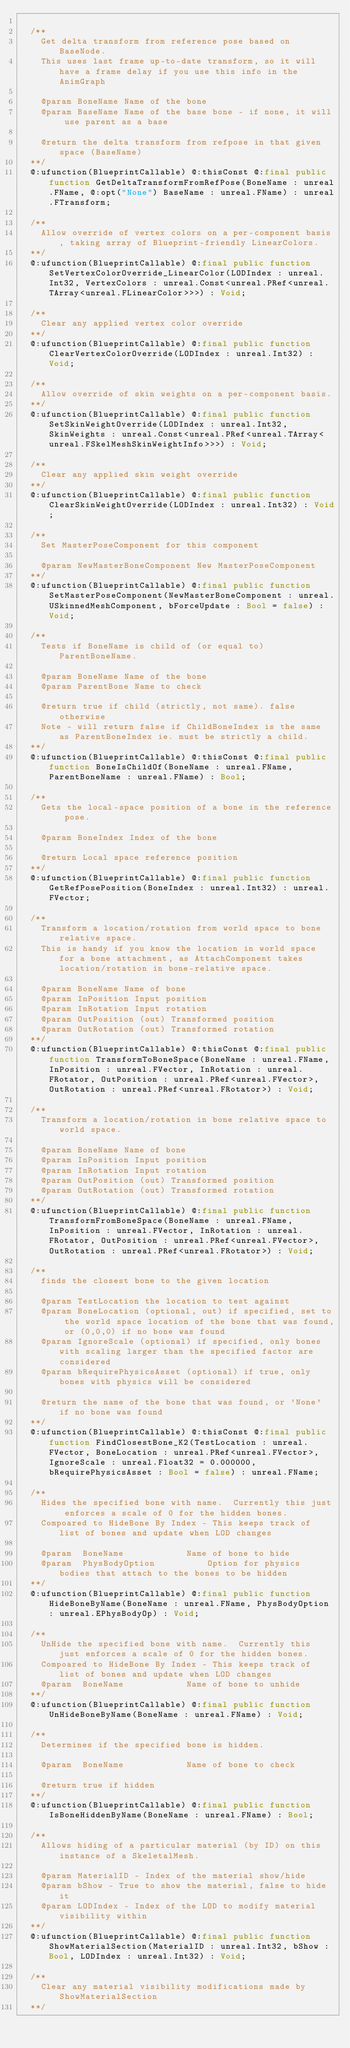<code> <loc_0><loc_0><loc_500><loc_500><_Haxe_>  
  /**
    Get delta transform from reference pose based on BaseNode.
    This uses last frame up-to-date transform, so it will have a frame delay if you use this info in the AnimGraph
    
    @param BoneName Name of the bone
    @param BaseName Name of the base bone - if none, it will use parent as a base
    
    @return the delta transform from refpose in that given space (BaseName)
  **/
  @:ufunction(BlueprintCallable) @:thisConst @:final public function GetDeltaTransformFromRefPose(BoneName : unreal.FName, @:opt("None") BaseName : unreal.FName) : unreal.FTransform;
  
  /**
    Allow override of vertex colors on a per-component basis, taking array of Blueprint-friendly LinearColors.
  **/
  @:ufunction(BlueprintCallable) @:final public function SetVertexColorOverride_LinearColor(LODIndex : unreal.Int32, VertexColors : unreal.Const<unreal.PRef<unreal.TArray<unreal.FLinearColor>>>) : Void;
  
  /**
    Clear any applied vertex color override
  **/
  @:ufunction(BlueprintCallable) @:final public function ClearVertexColorOverride(LODIndex : unreal.Int32) : Void;
  
  /**
    Allow override of skin weights on a per-component basis.
  **/
  @:ufunction(BlueprintCallable) @:final public function SetSkinWeightOverride(LODIndex : unreal.Int32, SkinWeights : unreal.Const<unreal.PRef<unreal.TArray<unreal.FSkelMeshSkinWeightInfo>>>) : Void;
  
  /**
    Clear any applied skin weight override
  **/
  @:ufunction(BlueprintCallable) @:final public function ClearSkinWeightOverride(LODIndex : unreal.Int32) : Void;
  
  /**
    Set MasterPoseComponent for this component
    
    @param NewMasterBoneComponent New MasterPoseComponent
  **/
  @:ufunction(BlueprintCallable) @:final public function SetMasterPoseComponent(NewMasterBoneComponent : unreal.USkinnedMeshComponent, bForceUpdate : Bool = false) : Void;
  
  /**
    Tests if BoneName is child of (or equal to) ParentBoneName.
    
    @param BoneName Name of the bone
    @param ParentBone Name to check
    
    @return true if child (strictly, not same). false otherwise
    Note - will return false if ChildBoneIndex is the same as ParentBoneIndex ie. must be strictly a child.
  **/
  @:ufunction(BlueprintCallable) @:thisConst @:final public function BoneIsChildOf(BoneName : unreal.FName, ParentBoneName : unreal.FName) : Bool;
  
  /**
    Gets the local-space position of a bone in the reference pose.
    
    @param BoneIndex Index of the bone
    
    @return Local space reference position
  **/
  @:ufunction(BlueprintCallable) @:final public function GetRefPosePosition(BoneIndex : unreal.Int32) : unreal.FVector;
  
  /**
    Transform a location/rotation from world space to bone relative space.
    This is handy if you know the location in world space for a bone attachment, as AttachComponent takes location/rotation in bone-relative space.
    
    @param BoneName Name of bone
    @param InPosition Input position
    @param InRotation Input rotation
    @param OutPosition (out) Transformed position
    @param OutRotation (out) Transformed rotation
  **/
  @:ufunction(BlueprintCallable) @:thisConst @:final public function TransformToBoneSpace(BoneName : unreal.FName, InPosition : unreal.FVector, InRotation : unreal.FRotator, OutPosition : unreal.PRef<unreal.FVector>, OutRotation : unreal.PRef<unreal.FRotator>) : Void;
  
  /**
    Transform a location/rotation in bone relative space to world space.
    
    @param BoneName Name of bone
    @param InPosition Input position
    @param InRotation Input rotation
    @param OutPosition (out) Transformed position
    @param OutRotation (out) Transformed rotation
  **/
  @:ufunction(BlueprintCallable) @:final public function TransformFromBoneSpace(BoneName : unreal.FName, InPosition : unreal.FVector, InRotation : unreal.FRotator, OutPosition : unreal.PRef<unreal.FVector>, OutRotation : unreal.PRef<unreal.FRotator>) : Void;
  
  /**
    finds the closest bone to the given location
    
    @param TestLocation the location to test against
    @param BoneLocation (optional, out) if specified, set to the world space location of the bone that was found, or (0,0,0) if no bone was found
    @param IgnoreScale (optional) if specified, only bones with scaling larger than the specified factor are considered
    @param bRequirePhysicsAsset (optional) if true, only bones with physics will be considered
    
    @return the name of the bone that was found, or 'None' if no bone was found
  **/
  @:ufunction(BlueprintCallable) @:thisConst @:final public function FindClosestBone_K2(TestLocation : unreal.FVector, BoneLocation : unreal.PRef<unreal.FVector>, IgnoreScale : unreal.Float32 = 0.000000, bRequirePhysicsAsset : Bool = false) : unreal.FName;
  
  /**
    Hides the specified bone with name.  Currently this just enforces a scale of 0 for the hidden bones.
    Compoared to HideBone By Index - This keeps track of list of bones and update when LOD changes
    
    @param  BoneName            Name of bone to hide
    @param  PhysBodyOption          Option for physics bodies that attach to the bones to be hidden
  **/
  @:ufunction(BlueprintCallable) @:final public function HideBoneByName(BoneName : unreal.FName, PhysBodyOption : unreal.EPhysBodyOp) : Void;
  
  /**
    UnHide the specified bone with name.  Currently this just enforces a scale of 0 for the hidden bones.
    Compoared to HideBone By Index - This keeps track of list of bones and update when LOD changes
    @param  BoneName            Name of bone to unhide
  **/
  @:ufunction(BlueprintCallable) @:final public function UnHideBoneByName(BoneName : unreal.FName) : Void;
  
  /**
    Determines if the specified bone is hidden.
    
    @param  BoneName            Name of bone to check
    
    @return true if hidden
  **/
  @:ufunction(BlueprintCallable) @:final public function IsBoneHiddenByName(BoneName : unreal.FName) : Bool;
  
  /**
    Allows hiding of a particular material (by ID) on this instance of a SkeletalMesh.
    
    @param MaterialID - Index of the material show/hide
    @param bShow - True to show the material, false to hide it
    @param LODIndex - Index of the LOD to modify material visibility within
  **/
  @:ufunction(BlueprintCallable) @:final public function ShowMaterialSection(MaterialID : unreal.Int32, bShow : Bool, LODIndex : unreal.Int32) : Void;
  
  /**
    Clear any material visibility modifications made by ShowMaterialSection
  **/</code> 